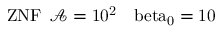Convert formula to latex. <formula><loc_0><loc_0><loc_500><loc_500>{ Z N F } \, \mathcal { A } = 1 0 ^ { 2 } \, \ b e t a _ { 0 } = 1 0</formula> 